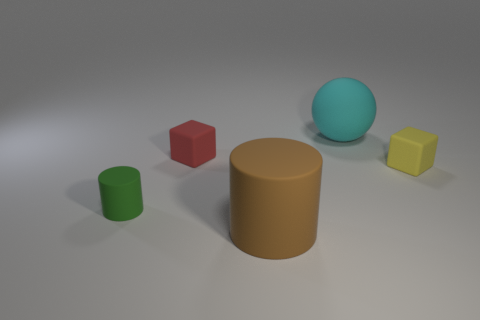Add 2 cyan things. How many objects exist? 7 Add 4 blocks. How many blocks are left? 6 Add 5 tiny green metal things. How many tiny green metal things exist? 5 Subtract 1 cyan balls. How many objects are left? 4 Subtract all cylinders. How many objects are left? 3 Subtract all big yellow objects. Subtract all small matte objects. How many objects are left? 2 